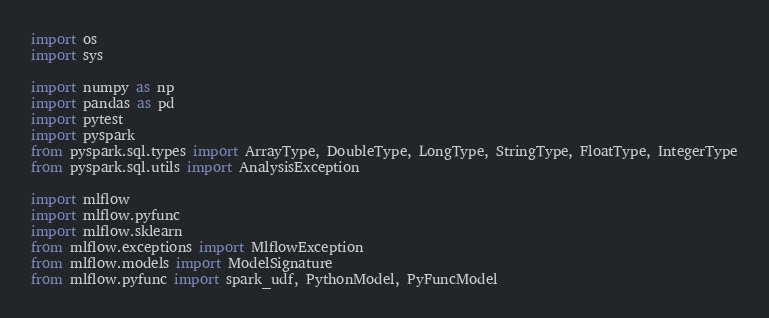<code> <loc_0><loc_0><loc_500><loc_500><_Python_>import os
import sys

import numpy as np
import pandas as pd
import pytest
import pyspark
from pyspark.sql.types import ArrayType, DoubleType, LongType, StringType, FloatType, IntegerType
from pyspark.sql.utils import AnalysisException

import mlflow
import mlflow.pyfunc
import mlflow.sklearn
from mlflow.exceptions import MlflowException
from mlflow.models import ModelSignature
from mlflow.pyfunc import spark_udf, PythonModel, PyFuncModel</code> 